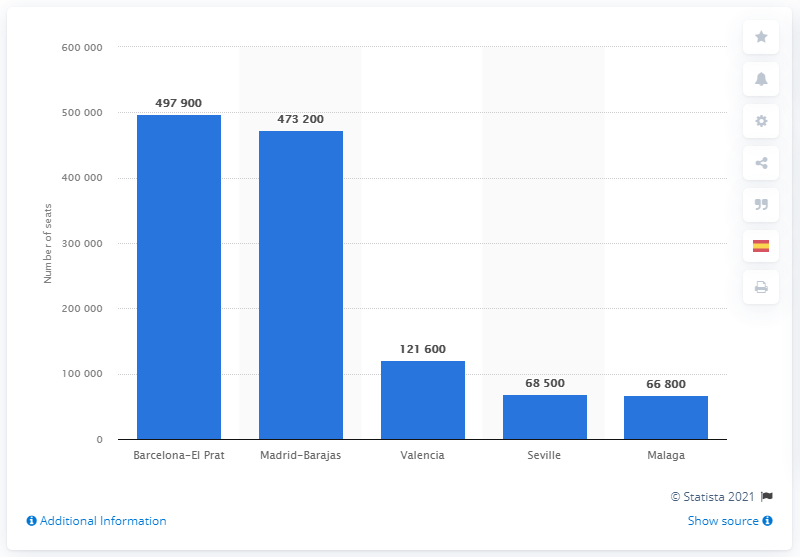List a handful of essential elements in this visual. Barcelona-El Prat Airport was the most impacted by the ban. 